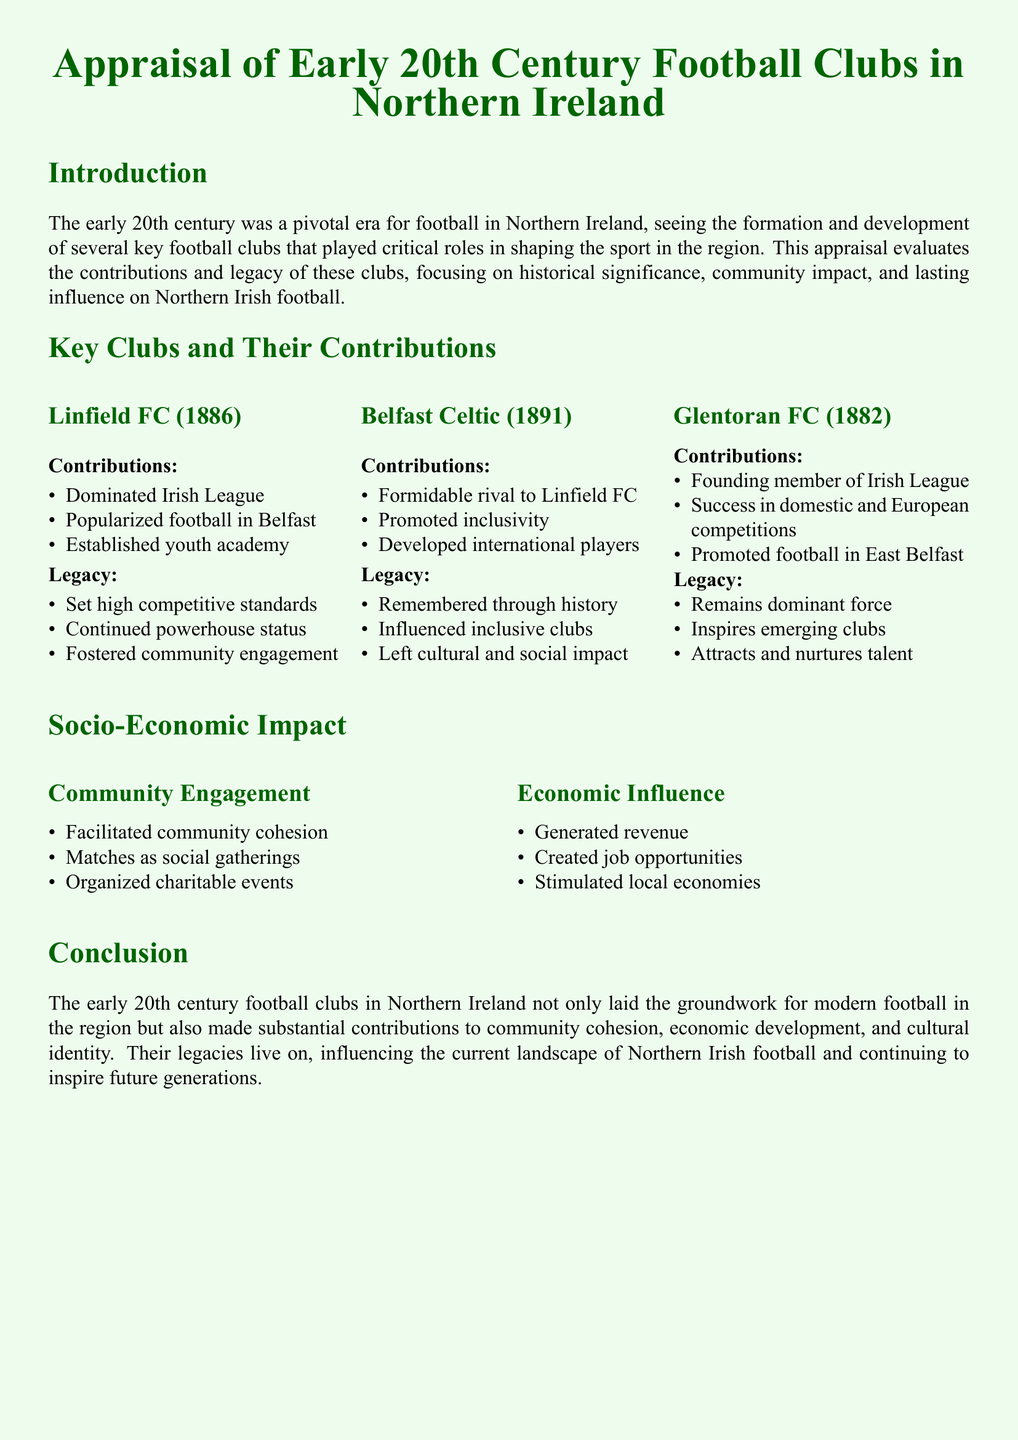What year was Linfield FC founded? Linfield FC was founded in 1886, as stated in the document.
Answer: 1886 Which club was a formidable rival to Linfield FC? The document mentions that Belfast Celtic was a formidable rival to Linfield FC.
Answer: Belfast Celtic What is one contribution of Glentoran FC? Glentoran FC is noted for being a founding member of the Irish League in the document.
Answer: Founding member of Irish League What impact did football clubs have on community engagement? The document states that they facilitated community cohesion as a key impact on engagement.
Answer: Community cohesion How did the football clubs influence the local economy? The document highlights that they generated revenue as a significant economic influence.
Answer: Generated revenue What legacy did Belfast Celtic leave? The document notes that Belfast Celtic is remembered through history.
Answer: Remembered through history What was a notable contribution of Linfield FC regarding youth? The document mentions that Linfield FC established a youth academy as part of its contributions.
Answer: Established youth academy Which area did Glentoran FC promote football in? The document indicates that Glentoran FC promoted football in East Belfast.
Answer: East Belfast What social activity did football matches facilitate? According to the document, matches served as social gatherings in the community.
Answer: Social gatherings 